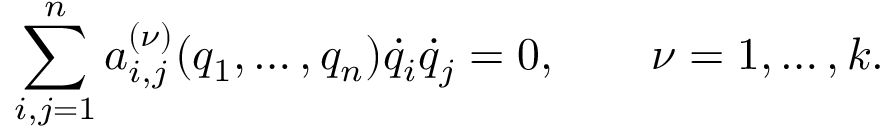Convert formula to latex. <formula><loc_0><loc_0><loc_500><loc_500>\sum _ { i , j = 1 } ^ { n } a _ { i , j } ^ { ( \nu ) } ( q _ { 1 } , \dots , q _ { n } ) { \dot { q } } _ { i } { \dot { q } } _ { j } = 0 , \quad \nu = 1 , \dots , k .</formula> 